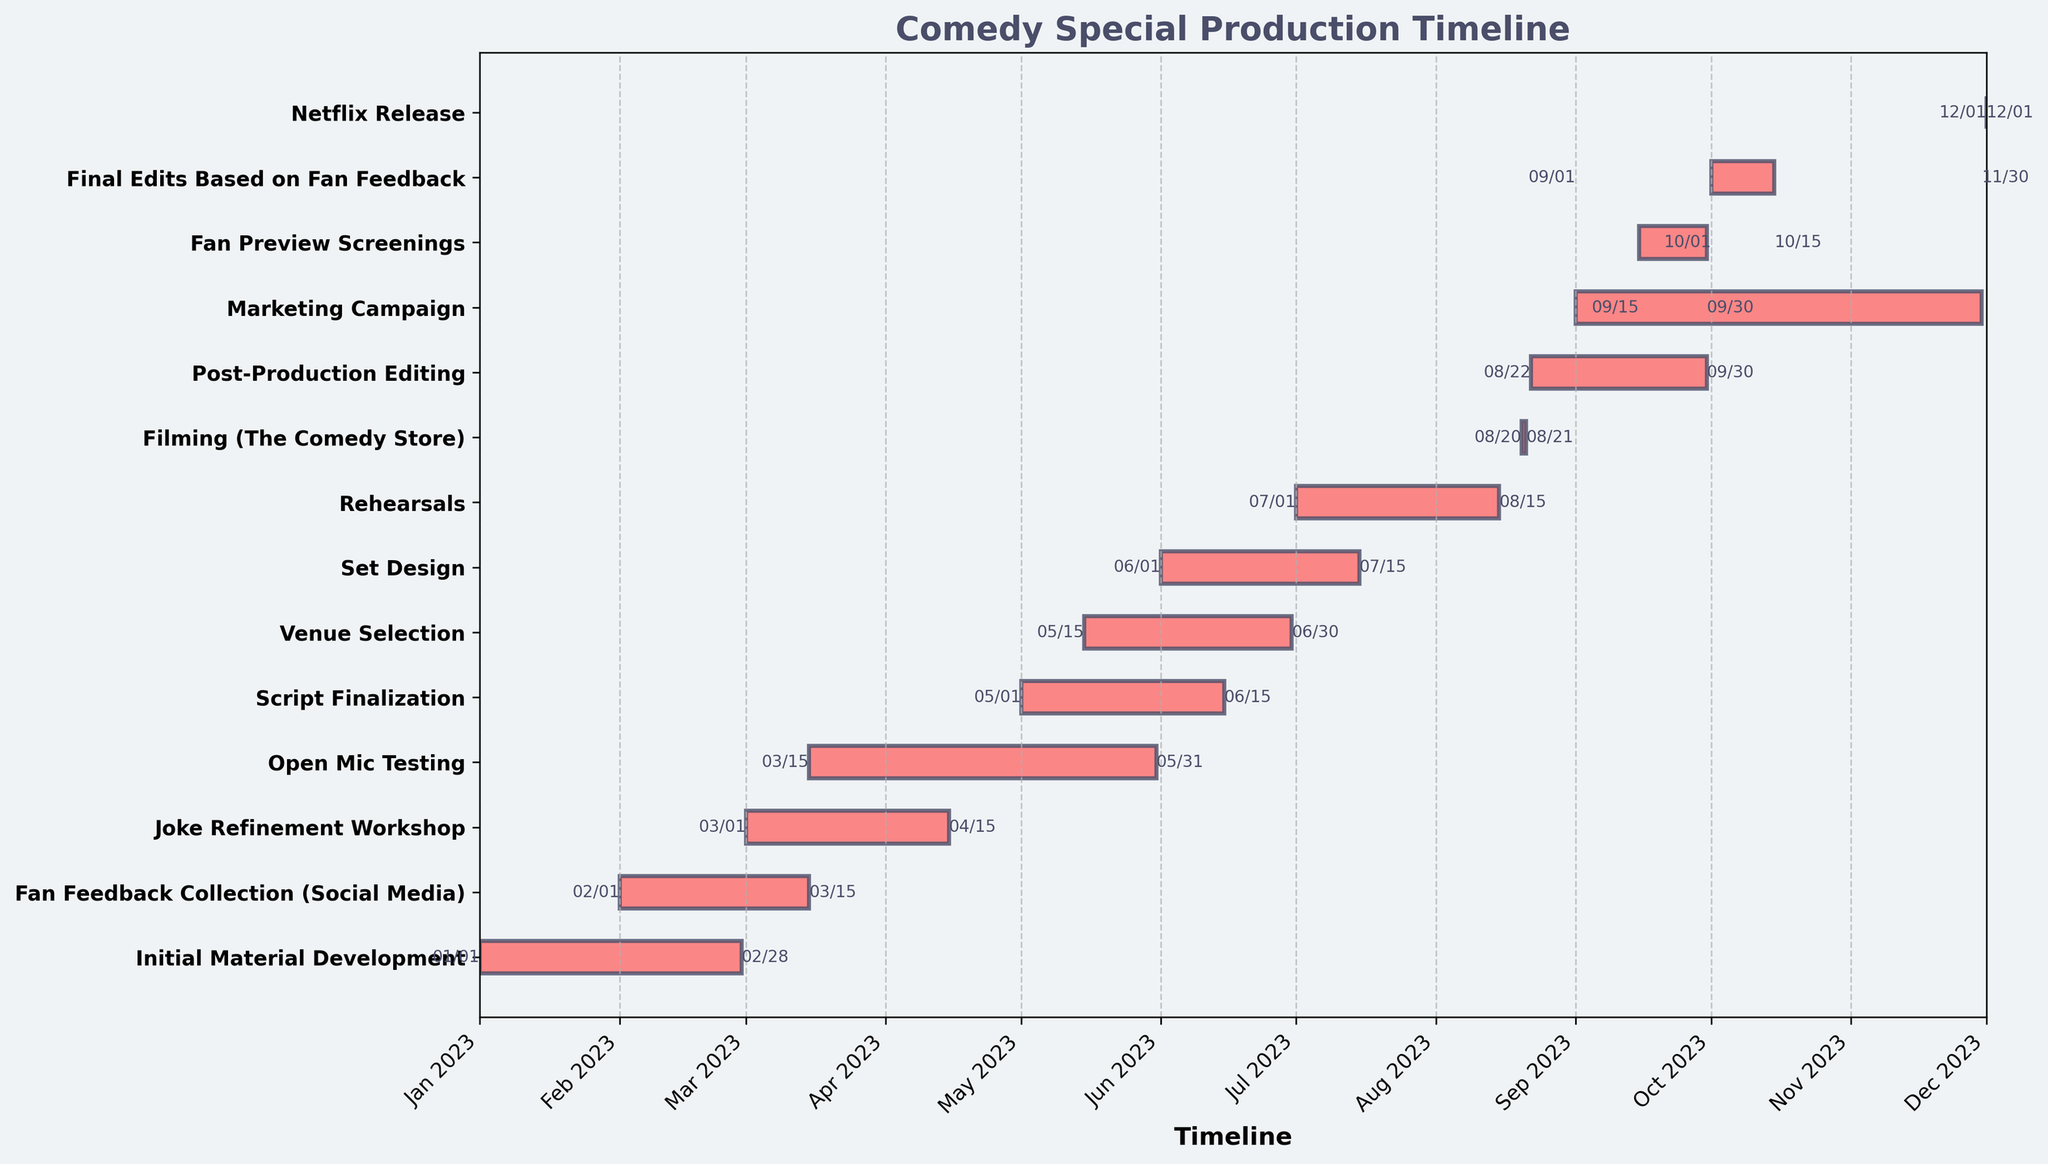How long does the entire comedy special production timeline span? The timeline starts with "Initial Material Development" on January 1, 2023, and ends with the "Netflix Release" on December 1, 2023. Calculate the difference between these two dates.
Answer: 11 months Which task has the shortest duration in the timeline? By looking at the horizontal bars, the shortest one represents "Filming (The Comedy Store)" which spans from August 20, 2023, to August 21, 2023.
Answer: Filming (The Comedy Store) Which tasks are ongoing during March 2023? From the timeline, the tasks overlapping March 2023 are "Initial Material Development", "Fan Feedback Collection (Social Media)", "Joke Refinement Workshop", and "Open Mic Testing".
Answer: Initial Material Development, Fan Feedback Collection (Social Media), Joke Refinement Workshop, Open Mic Testing How many tasks overlap with the "Set Design" phase? The "Set Design" phase from June 1 to July 15 overlaps with "Venue Selection", "Script Finalization" and "Rehearsals".
Answer: 3 tasks Which phase starts immediately after "Rehearsals"? The phase that starts immediately after "Rehearsals" (ending August 15, 2023) is "Filming (The Comedy Store)", which starts on August 20, 2023.
Answer: Filming (The Comedy Store) What are the total number of days allocated for editing tasks in the post-production phase? Sum the durations of "Post-Production Editing" (August 22 to September 30) and "Final Edits Based on Fan Feedback" (October 1 to October 15). Calculate the number of days for each: from August 22 to September 30 is 40 days, and from October 1 to October 15 is 15 days. The total is 40 + 15.
Answer: 55 days When does the "Marketing Campaign" start, and how long does it run? The "Marketing Campaign" starts on September 1, 2023, and ends on November 30, 2023. Calculate the difference between these two dates.
Answer: 3 months Which task overlaps the most with "Open Mic Testing"? Through visual inspection, "Fan Feedback Collection (Social Media)" overlaps the most with "Open Mic Testing" by spanning February 1, 2023, to March 15, 2023, and March 15 to May 31, 2023, respectively.
Answer: Fan Feedback Collection (Social Media) Which two consecutive tasks have the shortest gap between their end and start dates? By analyzing the bars, the gap between the end of "Rehearsals" (August 15, 2023) and the start of "Filming (The Comedy Store)" (August 20, 2023) is the shortest gap.
Answer: Rehearsals and Filming (The Comedy Store) Which task starts the earliest in the production timeline? The timeline shows that the "Initial Material Development" starts on January 1, 2023, which is the earliest start date.
Answer: Initial Material Development 